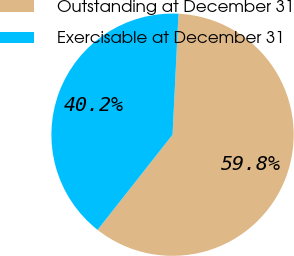<chart> <loc_0><loc_0><loc_500><loc_500><pie_chart><fcel>Outstanding at December 31<fcel>Exercisable at December 31<nl><fcel>59.84%<fcel>40.16%<nl></chart> 